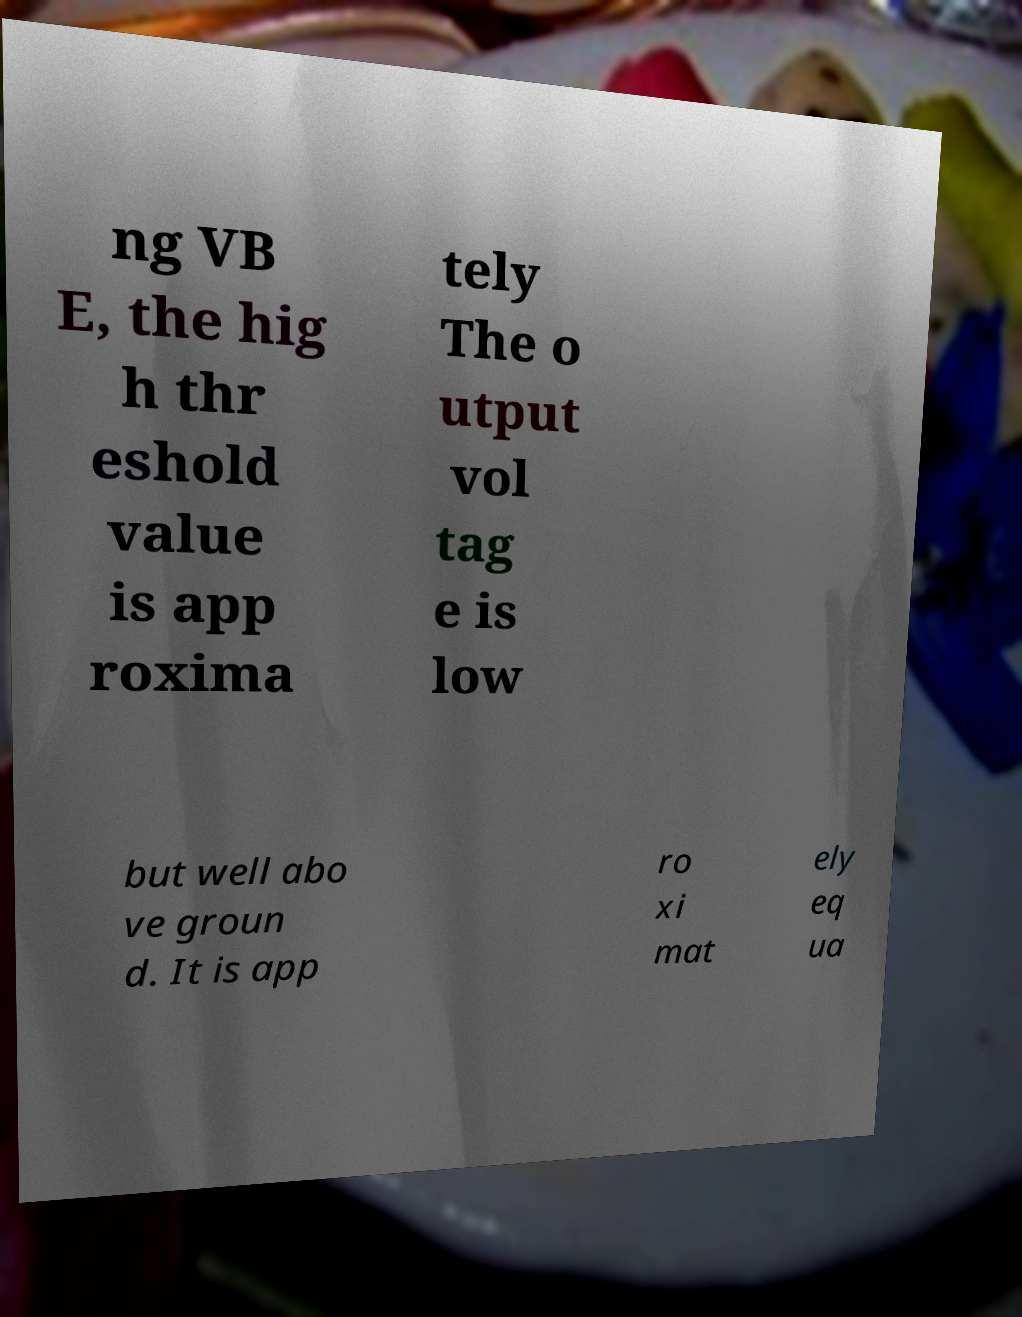For documentation purposes, I need the text within this image transcribed. Could you provide that? ng VB E, the hig h thr eshold value is app roxima tely The o utput vol tag e is low but well abo ve groun d. It is app ro xi mat ely eq ua 